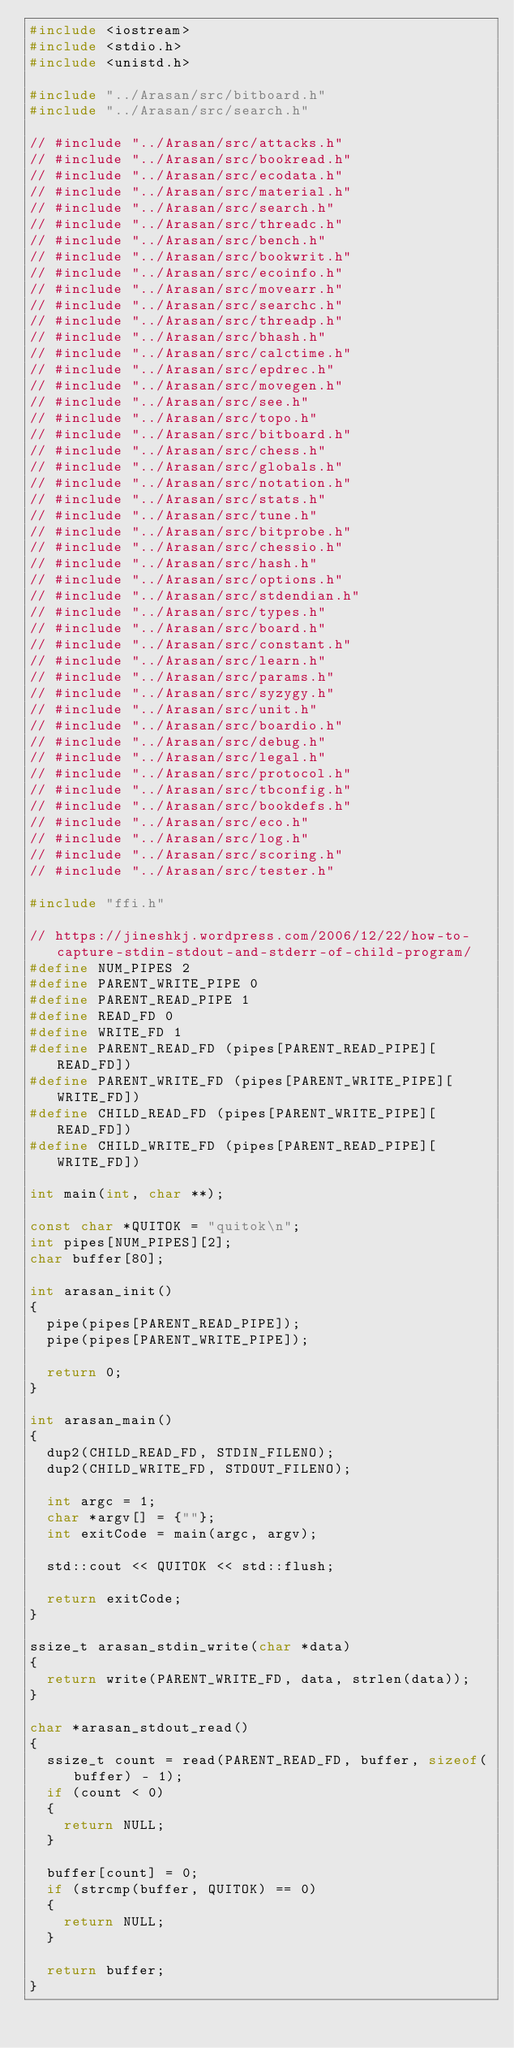<code> <loc_0><loc_0><loc_500><loc_500><_C++_>#include <iostream>
#include <stdio.h>
#include <unistd.h>

#include "../Arasan/src/bitboard.h"
#include "../Arasan/src/search.h"

// #include "../Arasan/src/attacks.h"
// #include "../Arasan/src/bookread.h"
// #include "../Arasan/src/ecodata.h"
// #include "../Arasan/src/material.h"
// #include "../Arasan/src/search.h"
// #include "../Arasan/src/threadc.h"
// #include "../Arasan/src/bench.h"
// #include "../Arasan/src/bookwrit.h"
// #include "../Arasan/src/ecoinfo.h"
// #include "../Arasan/src/movearr.h"
// #include "../Arasan/src/searchc.h"
// #include "../Arasan/src/threadp.h"
// #include "../Arasan/src/bhash.h"
// #include "../Arasan/src/calctime.h"
// #include "../Arasan/src/epdrec.h"
// #include "../Arasan/src/movegen.h"
// #include "../Arasan/src/see.h"
// #include "../Arasan/src/topo.h"
// #include "../Arasan/src/bitboard.h"
// #include "../Arasan/src/chess.h"
// #include "../Arasan/src/globals.h"
// #include "../Arasan/src/notation.h"
// #include "../Arasan/src/stats.h"
// #include "../Arasan/src/tune.h"
// #include "../Arasan/src/bitprobe.h"
// #include "../Arasan/src/chessio.h"
// #include "../Arasan/src/hash.h"
// #include "../Arasan/src/options.h"
// #include "../Arasan/src/stdendian.h"
// #include "../Arasan/src/types.h"
// #include "../Arasan/src/board.h"
// #include "../Arasan/src/constant.h"
// #include "../Arasan/src/learn.h"
// #include "../Arasan/src/params.h"
// #include "../Arasan/src/syzygy.h"
// #include "../Arasan/src/unit.h"
// #include "../Arasan/src/boardio.h"
// #include "../Arasan/src/debug.h"
// #include "../Arasan/src/legal.h"
// #include "../Arasan/src/protocol.h"
// #include "../Arasan/src/tbconfig.h"
// #include "../Arasan/src/bookdefs.h"
// #include "../Arasan/src/eco.h"
// #include "../Arasan/src/log.h"
// #include "../Arasan/src/scoring.h"
// #include "../Arasan/src/tester.h"

#include "ffi.h"

// https://jineshkj.wordpress.com/2006/12/22/how-to-capture-stdin-stdout-and-stderr-of-child-program/
#define NUM_PIPES 2
#define PARENT_WRITE_PIPE 0
#define PARENT_READ_PIPE 1
#define READ_FD 0
#define WRITE_FD 1
#define PARENT_READ_FD (pipes[PARENT_READ_PIPE][READ_FD])
#define PARENT_WRITE_FD (pipes[PARENT_WRITE_PIPE][WRITE_FD])
#define CHILD_READ_FD (pipes[PARENT_WRITE_PIPE][READ_FD])
#define CHILD_WRITE_FD (pipes[PARENT_READ_PIPE][WRITE_FD])

int main(int, char **);

const char *QUITOK = "quitok\n";
int pipes[NUM_PIPES][2];
char buffer[80];

int arasan_init()
{
  pipe(pipes[PARENT_READ_PIPE]);
  pipe(pipes[PARENT_WRITE_PIPE]);

  return 0;
}

int arasan_main()
{
  dup2(CHILD_READ_FD, STDIN_FILENO);
  dup2(CHILD_WRITE_FD, STDOUT_FILENO);

  int argc = 1;
  char *argv[] = {""};
  int exitCode = main(argc, argv);

  std::cout << QUITOK << std::flush;

  return exitCode;
}

ssize_t arasan_stdin_write(char *data)
{
  return write(PARENT_WRITE_FD, data, strlen(data));
}

char *arasan_stdout_read()
{
  ssize_t count = read(PARENT_READ_FD, buffer, sizeof(buffer) - 1);
  if (count < 0)
  {
    return NULL;
  }

  buffer[count] = 0;
  if (strcmp(buffer, QUITOK) == 0)
  {
    return NULL;
  }

  return buffer;
}
</code> 